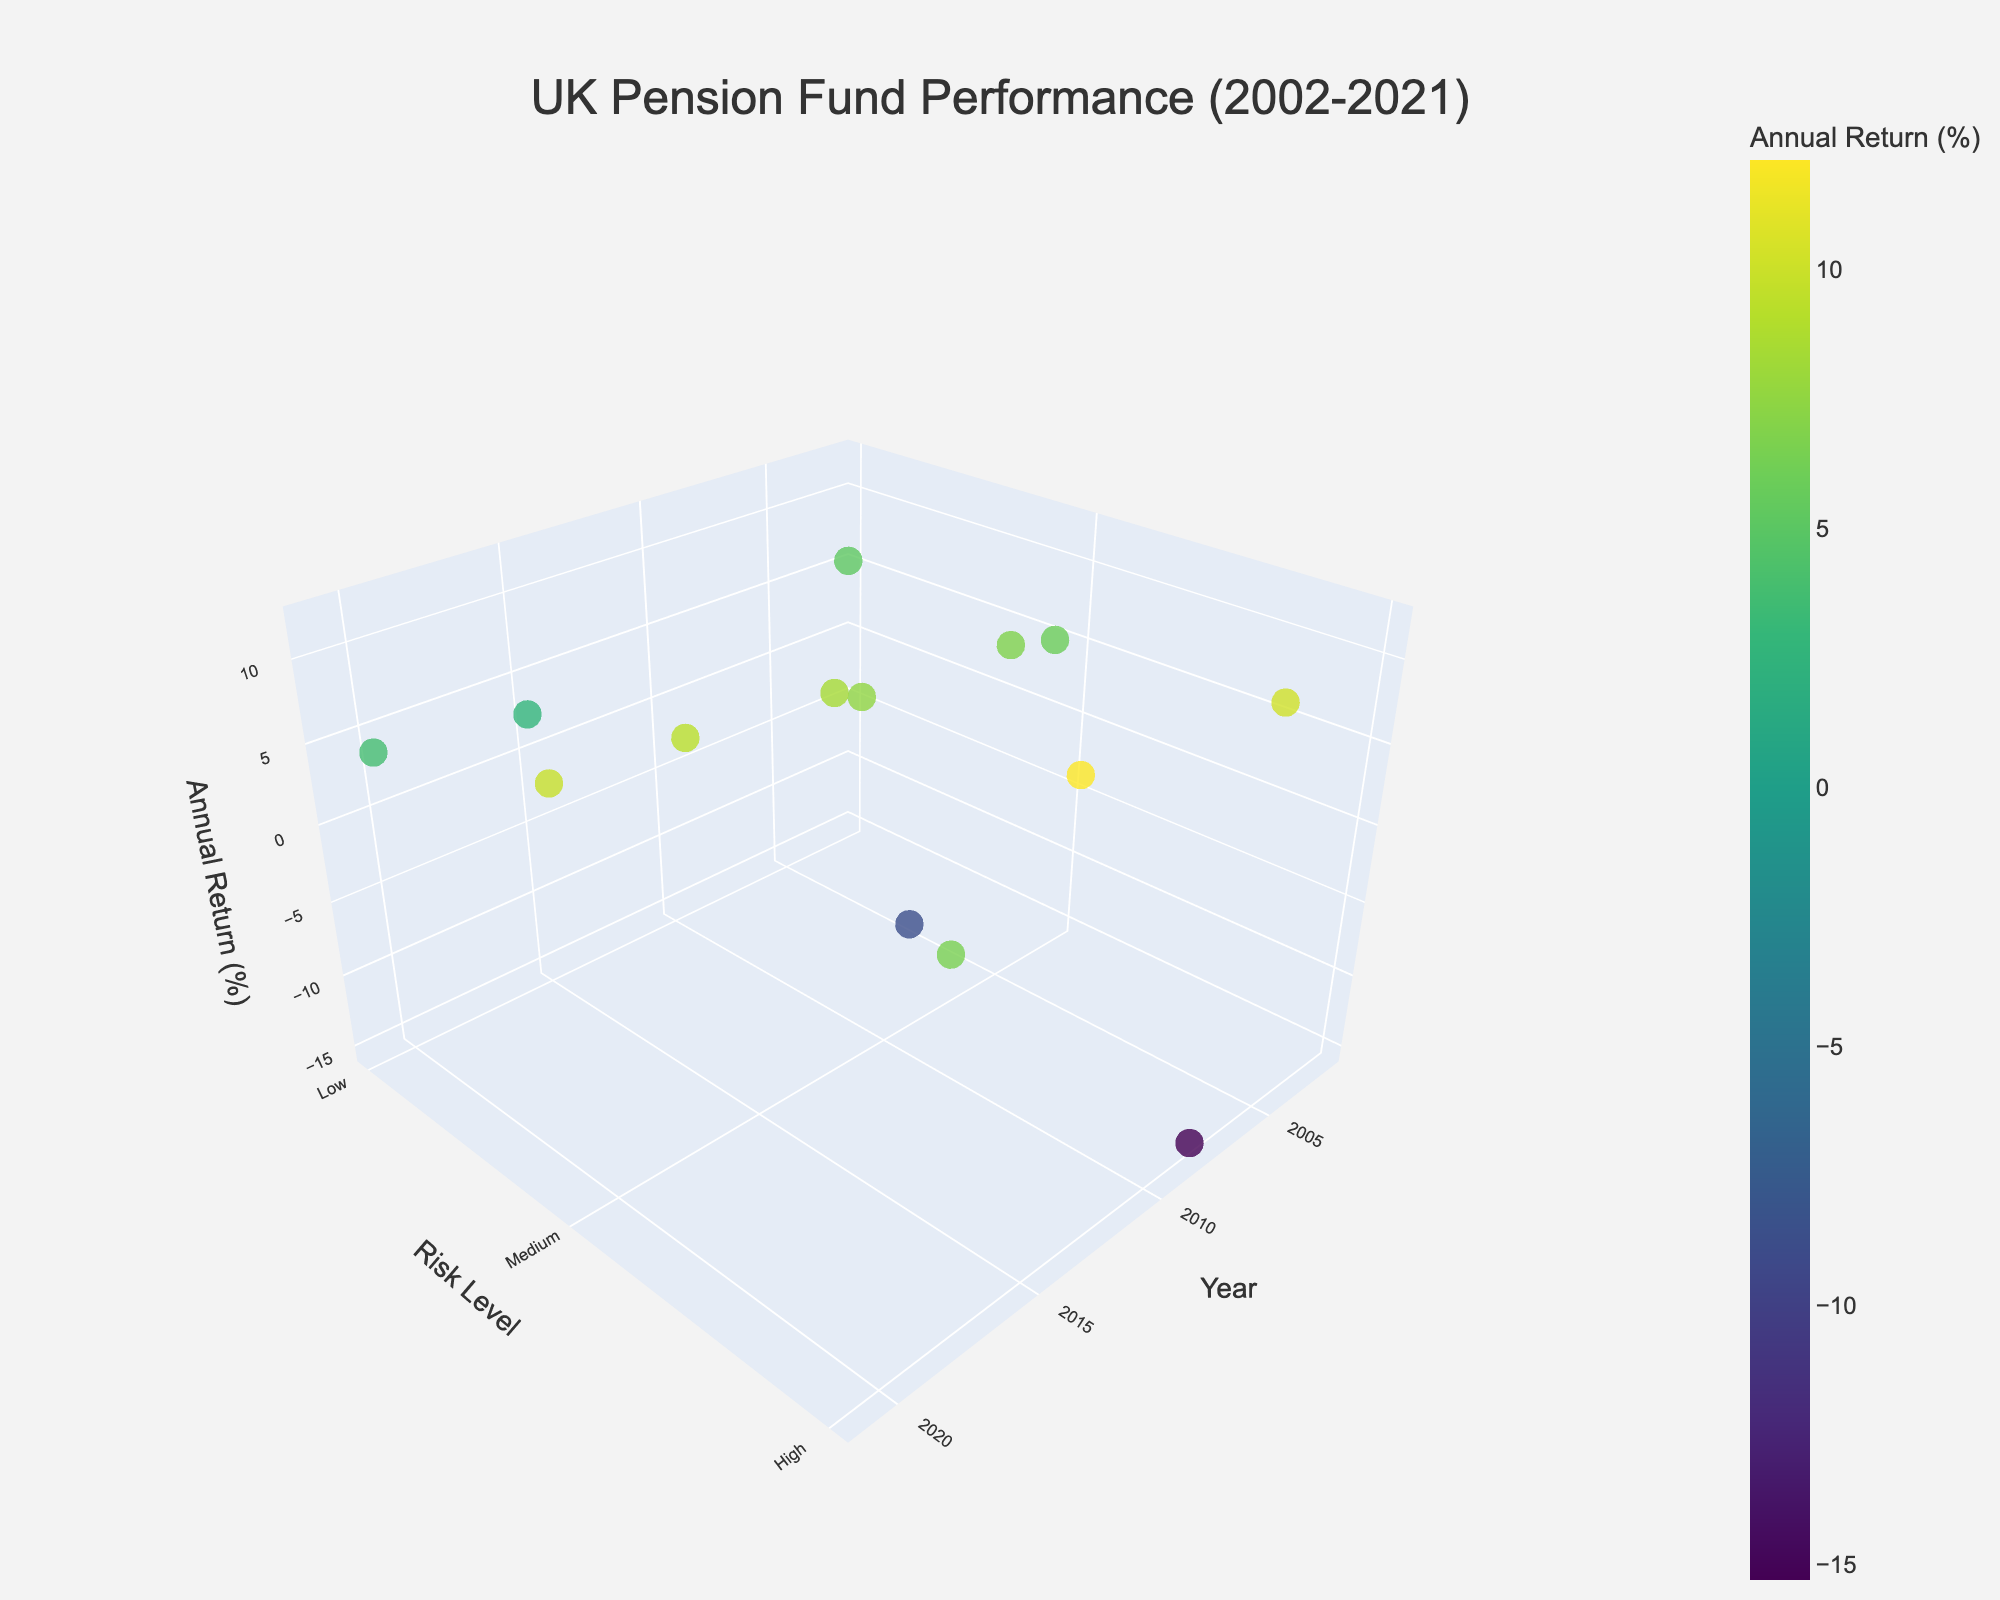What is the title of the plot? The title of the plot is displayed at the top center and reads "UK Pension Fund Performance (2002-2021)".
Answer: UK Pension Fund Performance (2002-2021) How many data points are plotted in the figure? By counting the markers in the 3D scatter plot, we observe that there are 14 data points.
Answer: 14 Which investment type had the highest annual return and what was the return? By inspecting the markers with the highest 'Annual Return (%)' value and hovering over them, we can see that "Real Estate" in 2021 during the recovery economic cycle had the highest annual return of 9.8%.
Answer: Real Estate, 9.8% During recessions, which investment type showed the lowest annual return? To find the lowest annual return during recessions, we filter the markers associated with recessions and compare their 'Annual Return (%)'. Equities in 2008 had the lowest return of -15.3%.
Answer: Equities, -15.3% In which year did equities have the highest annual return? By identifying the data points tagged with "Equities" and comparing the years, we see that 2014 saw the highest annual return for equities, with a rate of 12.1%.
Answer: 2014 What is the average annual return of government bonds across all years? The annual returns for government bonds are 5.2% (2002), 3.8% (2020), and 2.7% (2015). Adding these and dividing by the number of instances: (5.2 + 3.8 + 2.7) / 3 = 3.9%.
Answer: 3.9% Compare the annual returns of corporate bonds during growth and recovery economic cycles. Which is higher? By comparing the markers marked with "Corporate Bonds" in growth and recovery cycles, we see that during the growth cycle (2005) the return was 6.8%, and during the recovery cycle (2003) it was 5.9%. Therefore, the growth cycle had a higher return.
Answer: Growth cycle, 6.8% Which risk level appears to have the most data points? By counting the markers categorized by risk levels, we see that the medium risk level has the most data points: Corporate Bonds (2), Real Estate (3), and Index Funds (2).
Answer: Medium When did real estate have a negative annual return, and what was the economic cycle at that time? Observing the markers tagged with "Real Estate" with returns less than 0%, we note that in 2009, real estate had a -8.7% return during a recession.
Answer: 2009, recession How does the performance of government bonds compare during recessions in 2002 and 2020? Comparing the markers for government bonds during the recession years 2002 and 2020, we notice that the annual return in 2002 was 5.2%, whereas in 2020 it was 3.8%. Therefore, government bonds performed better in 2002.
Answer: 2002, better performance 